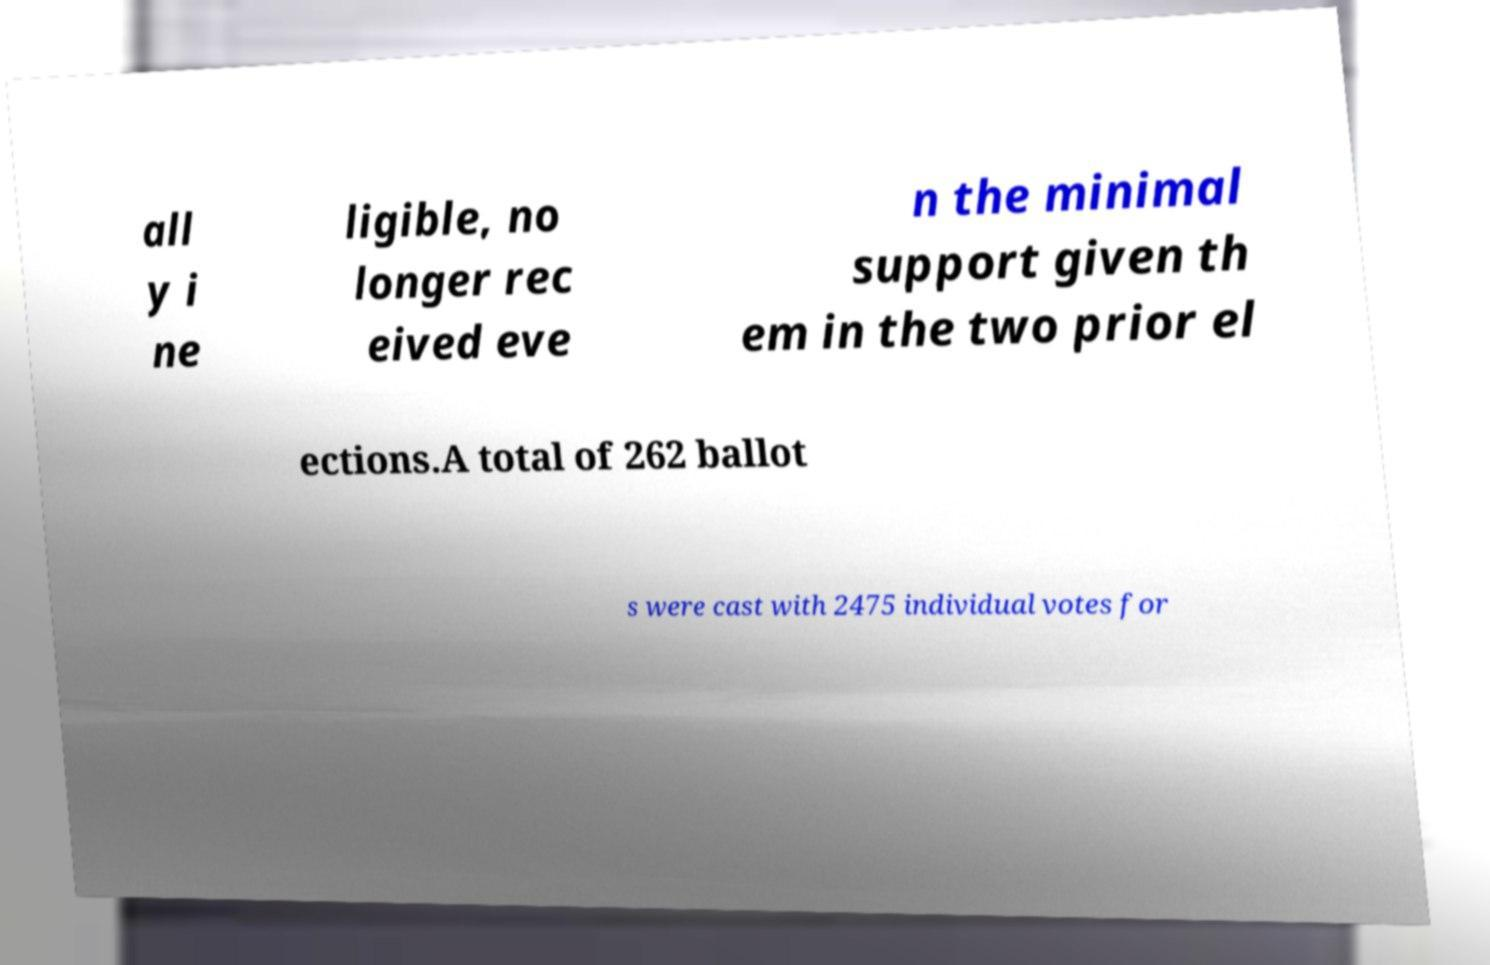Please read and relay the text visible in this image. What does it say? all y i ne ligible, no longer rec eived eve n the minimal support given th em in the two prior el ections.A total of 262 ballot s were cast with 2475 individual votes for 